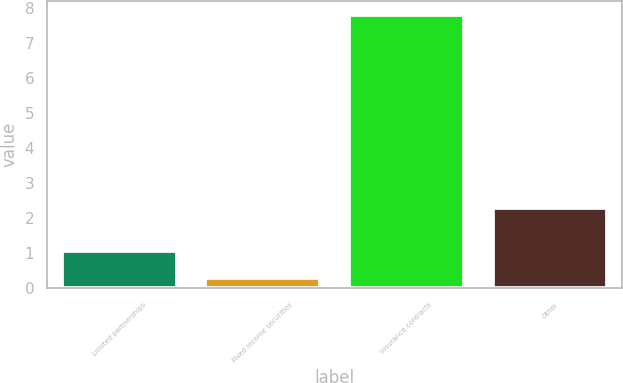Convert chart to OTSL. <chart><loc_0><loc_0><loc_500><loc_500><bar_chart><fcel>Limited partnerships<fcel>Fixed income securities<fcel>Insurance contracts<fcel>Other<nl><fcel>1.05<fcel>0.3<fcel>7.8<fcel>2.27<nl></chart> 